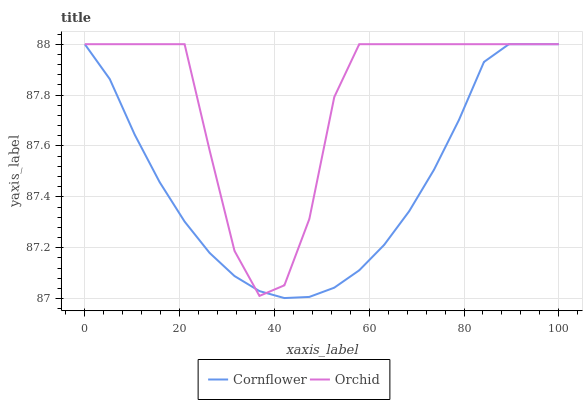Does Cornflower have the minimum area under the curve?
Answer yes or no. Yes. Does Orchid have the maximum area under the curve?
Answer yes or no. Yes. Does Orchid have the minimum area under the curve?
Answer yes or no. No. Is Cornflower the smoothest?
Answer yes or no. Yes. Is Orchid the roughest?
Answer yes or no. Yes. Is Orchid the smoothest?
Answer yes or no. No. Does Cornflower have the lowest value?
Answer yes or no. Yes. Does Orchid have the lowest value?
Answer yes or no. No. Does Orchid have the highest value?
Answer yes or no. Yes. Does Orchid intersect Cornflower?
Answer yes or no. Yes. Is Orchid less than Cornflower?
Answer yes or no. No. Is Orchid greater than Cornflower?
Answer yes or no. No. 